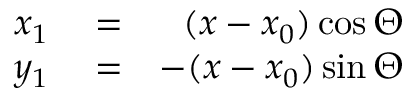<formula> <loc_0><loc_0><loc_500><loc_500>\begin{array} { r l r } { x _ { 1 } } & = } & { ( x - x _ { 0 } ) \cos \Theta } \\ { y _ { 1 } } & = } & { - ( x - x _ { 0 } ) \sin \Theta } \end{array}</formula> 